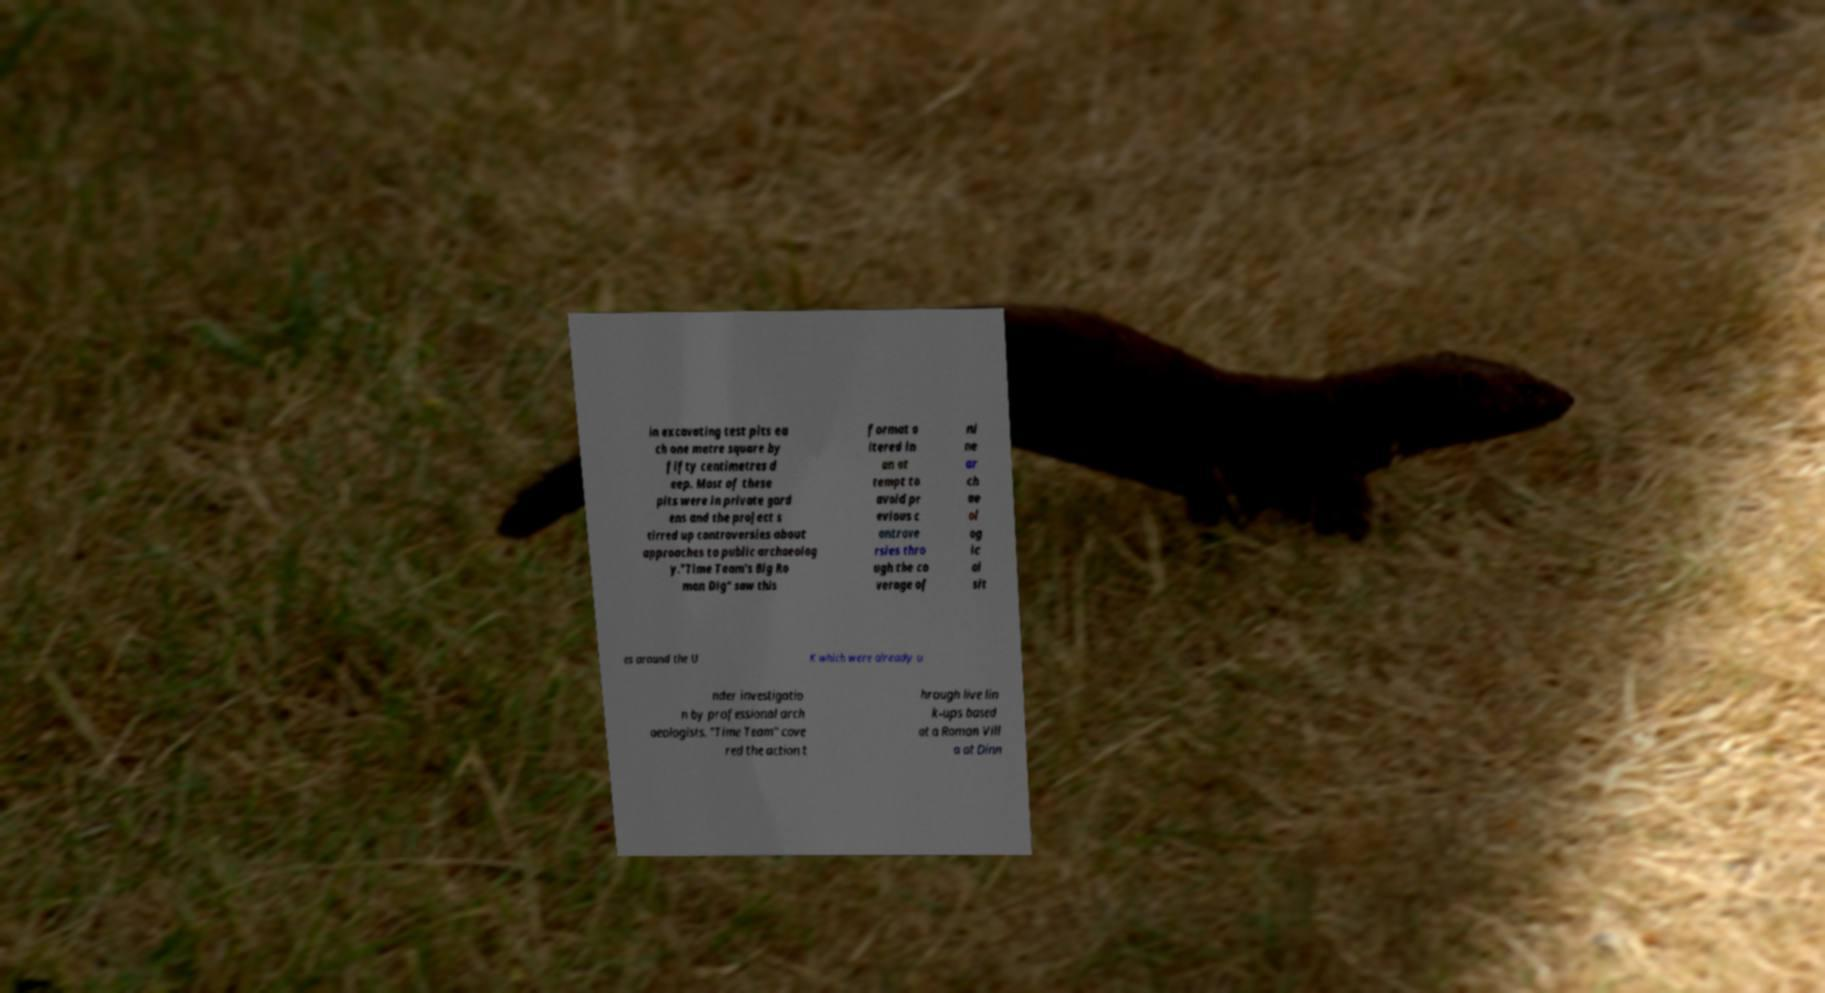Can you accurately transcribe the text from the provided image for me? in excavating test pits ea ch one metre square by fifty centimetres d eep. Most of these pits were in private gard ens and the project s tirred up controversies about approaches to public archaeolog y."Time Team's Big Ro man Dig" saw this format a ltered in an at tempt to avoid pr evious c ontrove rsies thro ugh the co verage of ni ne ar ch ae ol og ic al sit es around the U K which were already u nder investigatio n by professional arch aeologists. "Time Team" cove red the action t hrough live lin k-ups based at a Roman Vill a at Dinn 